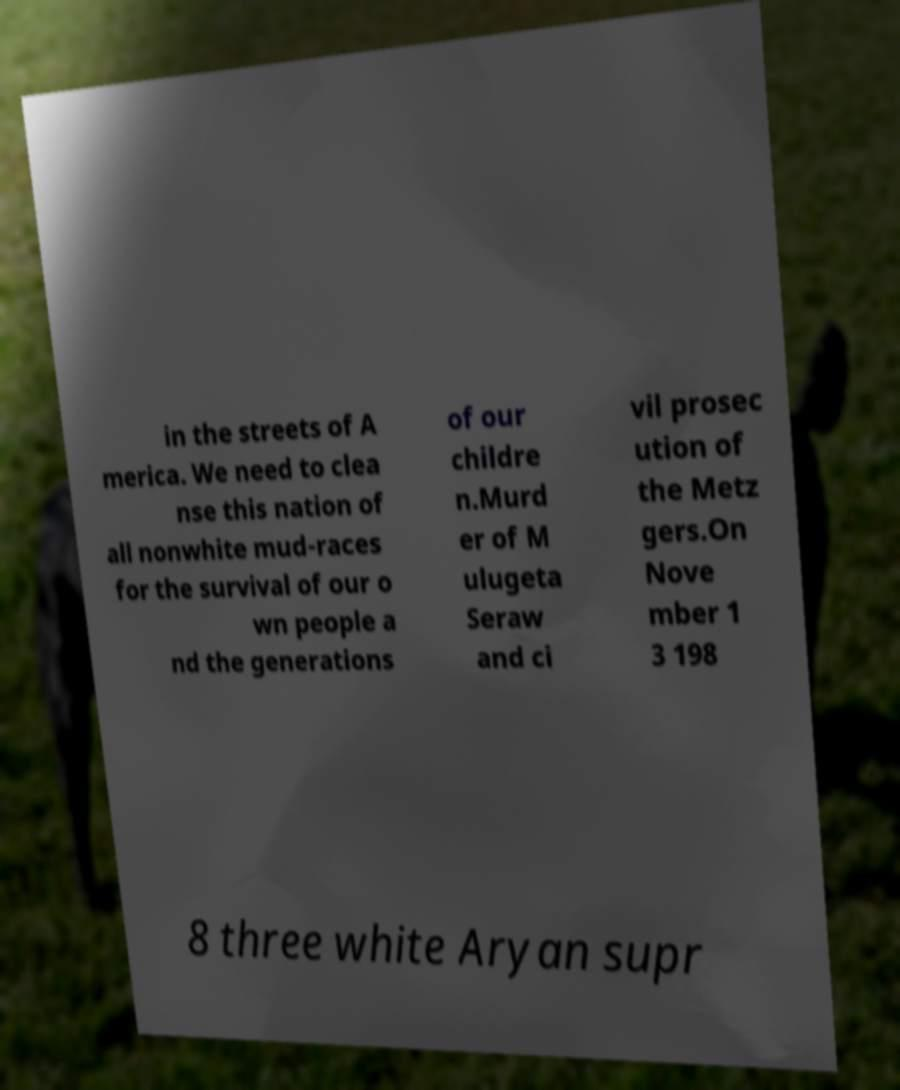For documentation purposes, I need the text within this image transcribed. Could you provide that? in the streets of A merica. We need to clea nse this nation of all nonwhite mud-races for the survival of our o wn people a nd the generations of our childre n.Murd er of M ulugeta Seraw and ci vil prosec ution of the Metz gers.On Nove mber 1 3 198 8 three white Aryan supr 